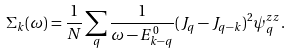Convert formula to latex. <formula><loc_0><loc_0><loc_500><loc_500>\Sigma _ { k } ( \omega ) = \frac { 1 } { N } \sum _ { q } \frac { 1 } { \omega - E _ { k - q } ^ { 0 } } ( J _ { q } - J _ { q - k } ) ^ { 2 } \psi _ { q } ^ { z z } .</formula> 